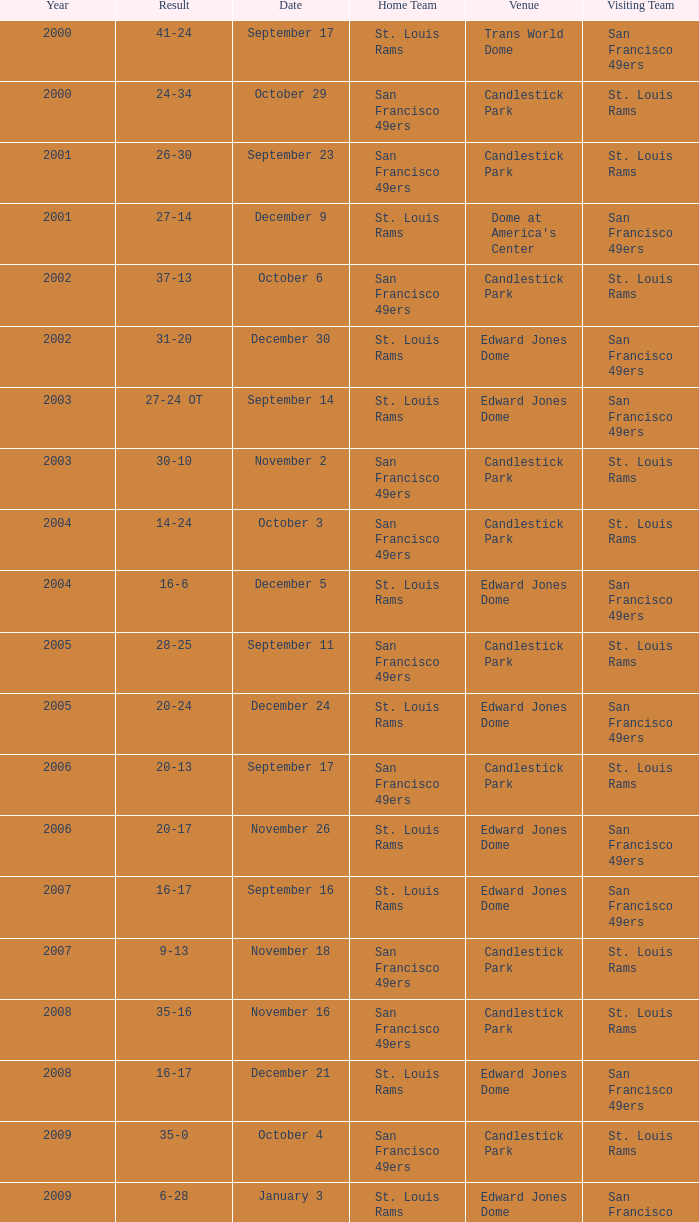What is the Venue of the 2009 St. Louis Rams Home game? Edward Jones Dome. 